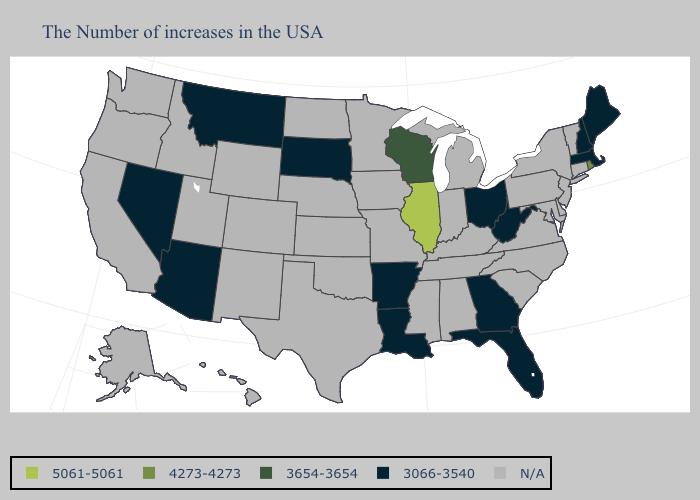What is the highest value in the USA?
Be succinct. 5061-5061. What is the value of Mississippi?
Short answer required. N/A. Does Rhode Island have the lowest value in the Northeast?
Give a very brief answer. No. Name the states that have a value in the range N/A?
Be succinct. Vermont, Connecticut, New York, New Jersey, Delaware, Maryland, Pennsylvania, Virginia, North Carolina, South Carolina, Michigan, Kentucky, Indiana, Alabama, Tennessee, Mississippi, Missouri, Minnesota, Iowa, Kansas, Nebraska, Oklahoma, Texas, North Dakota, Wyoming, Colorado, New Mexico, Utah, Idaho, California, Washington, Oregon, Alaska, Hawaii. Name the states that have a value in the range N/A?
Give a very brief answer. Vermont, Connecticut, New York, New Jersey, Delaware, Maryland, Pennsylvania, Virginia, North Carolina, South Carolina, Michigan, Kentucky, Indiana, Alabama, Tennessee, Mississippi, Missouri, Minnesota, Iowa, Kansas, Nebraska, Oklahoma, Texas, North Dakota, Wyoming, Colorado, New Mexico, Utah, Idaho, California, Washington, Oregon, Alaska, Hawaii. Is the legend a continuous bar?
Short answer required. No. Which states have the lowest value in the USA?
Give a very brief answer. Maine, Massachusetts, New Hampshire, West Virginia, Ohio, Florida, Georgia, Louisiana, Arkansas, South Dakota, Montana, Arizona, Nevada. Is the legend a continuous bar?
Quick response, please. No. What is the value of South Dakota?
Answer briefly. 3066-3540. Does Rhode Island have the lowest value in the Northeast?
Short answer required. No. Name the states that have a value in the range 4273-4273?
Give a very brief answer. Rhode Island. Does the map have missing data?
Keep it brief. Yes. What is the highest value in the USA?
Keep it brief. 5061-5061. Name the states that have a value in the range 4273-4273?
Concise answer only. Rhode Island. 